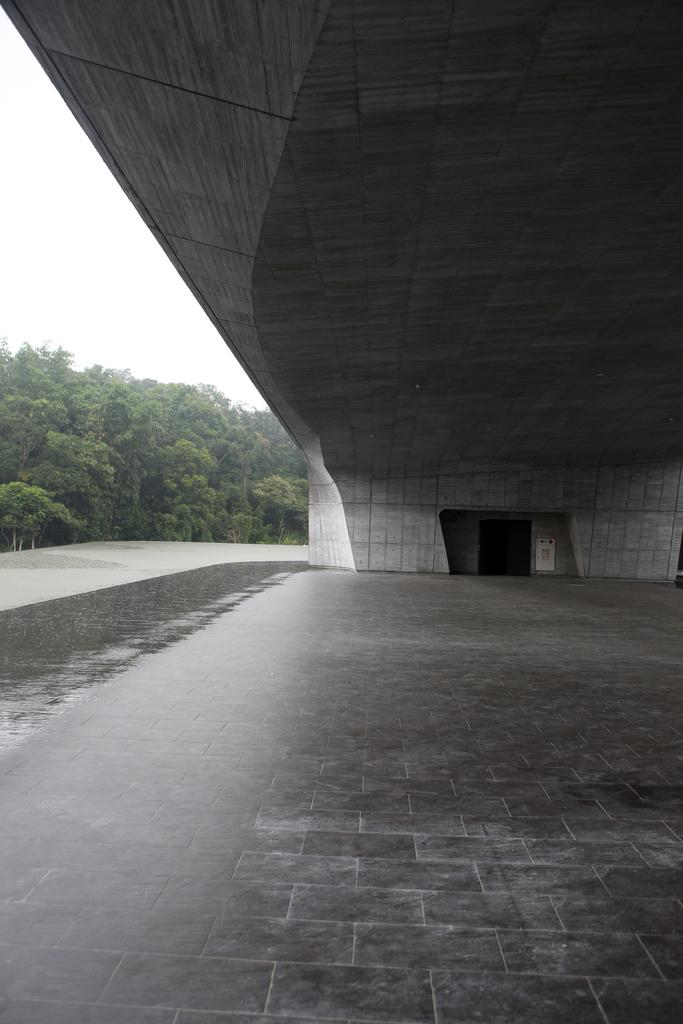What structure is present in the image? There is a bridge in the image. What feature does the bridge have? The bridge has a door. What type of surface is visible at the bottom of the image? There are tiles at the bottom of the image. What type of vegetation can be seen towards the left side of the image? There are trees visible towards the left side of the image. What is visible in the background of the image? The sky is visible in the image. What type of jellyfish can be seen swimming under the bridge in the image? There are no jellyfish present in the image; it features a bridge with a door and a surrounding environment that includes trees and tiles. 